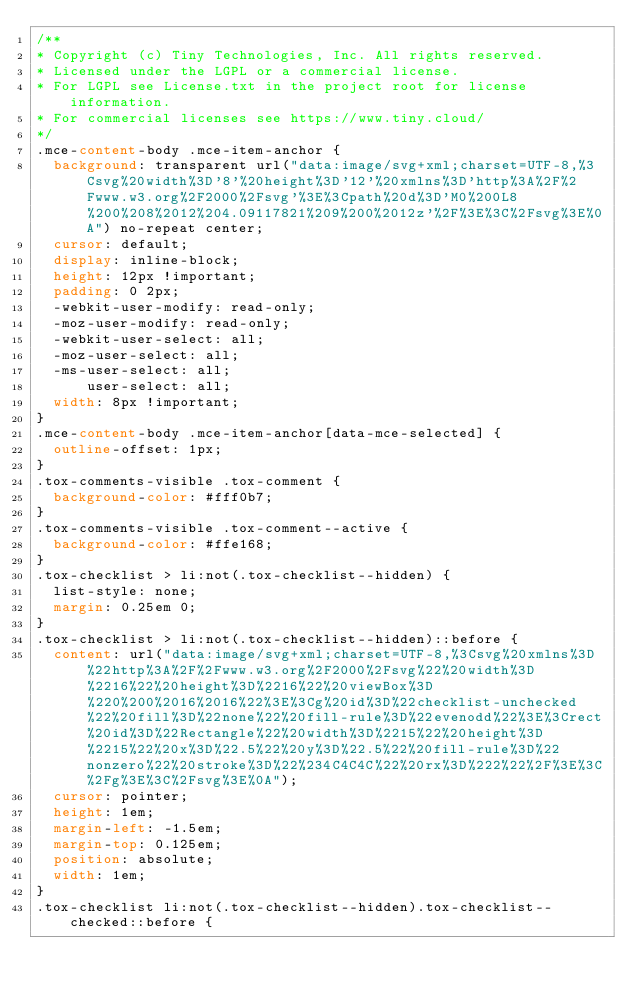Convert code to text. <code><loc_0><loc_0><loc_500><loc_500><_CSS_>/**
* Copyright (c) Tiny Technologies, Inc. All rights reserved.
* Licensed under the LGPL or a commercial license.
* For LGPL see License.txt in the project root for license information.
* For commercial licenses see https://www.tiny.cloud/
*/
.mce-content-body .mce-item-anchor {
  background: transparent url("data:image/svg+xml;charset=UTF-8,%3Csvg%20width%3D'8'%20height%3D'12'%20xmlns%3D'http%3A%2F%2Fwww.w3.org%2F2000%2Fsvg'%3E%3Cpath%20d%3D'M0%200L8%200%208%2012%204.09117821%209%200%2012z'%2F%3E%3C%2Fsvg%3E%0A") no-repeat center;
  cursor: default;
  display: inline-block;
  height: 12px !important;
  padding: 0 2px;
  -webkit-user-modify: read-only;
  -moz-user-modify: read-only;
  -webkit-user-select: all;
  -moz-user-select: all;
  -ms-user-select: all;
      user-select: all;
  width: 8px !important;
}
.mce-content-body .mce-item-anchor[data-mce-selected] {
  outline-offset: 1px;
}
.tox-comments-visible .tox-comment {
  background-color: #fff0b7;
}
.tox-comments-visible .tox-comment--active {
  background-color: #ffe168;
}
.tox-checklist > li:not(.tox-checklist--hidden) {
  list-style: none;
  margin: 0.25em 0;
}
.tox-checklist > li:not(.tox-checklist--hidden)::before {
  content: url("data:image/svg+xml;charset=UTF-8,%3Csvg%20xmlns%3D%22http%3A%2F%2Fwww.w3.org%2F2000%2Fsvg%22%20width%3D%2216%22%20height%3D%2216%22%20viewBox%3D%220%200%2016%2016%22%3E%3Cg%20id%3D%22checklist-unchecked%22%20fill%3D%22none%22%20fill-rule%3D%22evenodd%22%3E%3Crect%20id%3D%22Rectangle%22%20width%3D%2215%22%20height%3D%2215%22%20x%3D%22.5%22%20y%3D%22.5%22%20fill-rule%3D%22nonzero%22%20stroke%3D%22%234C4C4C%22%20rx%3D%222%22%2F%3E%3C%2Fg%3E%3C%2Fsvg%3E%0A");
  cursor: pointer;
  height: 1em;
  margin-left: -1.5em;
  margin-top: 0.125em;
  position: absolute;
  width: 1em;
}
.tox-checklist li:not(.tox-checklist--hidden).tox-checklist--checked::before {</code> 